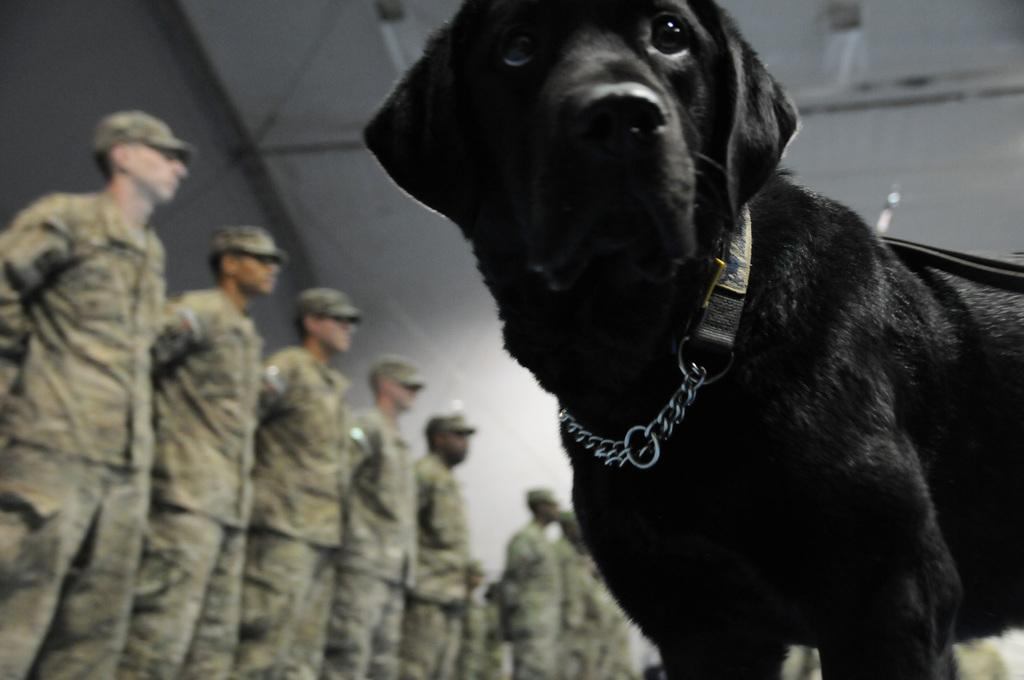What type of animal is in the image? There is a black dog in the image. What is unique about the dog's appearance? The dog has a belt. Who else is present in the image? There are people standing in the image. What are the people wearing? The people are wearing military dresses. How many buttons can be seen on the dog's underwear in the image? There is no underwear or buttons present on the dog in the image. Can you spot an ant crawling on the people's military dresses in the image? There is no ant visible in the image. 